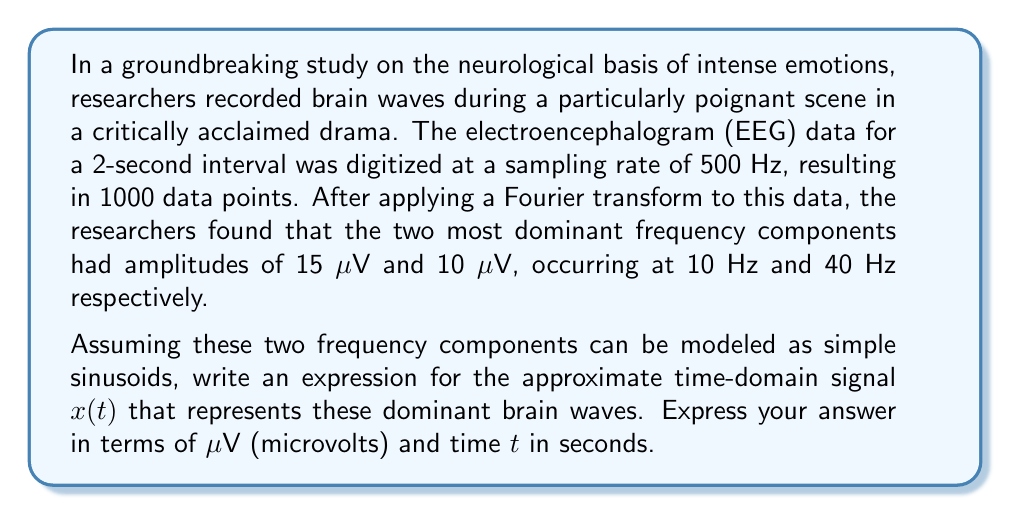Solve this math problem. To solve this problem, we need to understand how the Fourier transform relates to sinusoidal components in the time domain. Each frequency component in the Fourier domain corresponds to a sinusoid in the time domain.

Given:
- Dominant frequency 1: 10 Hz with amplitude 15 μV
- Dominant frequency 2: 40 Hz with amplitude 10 μV

Step 1: Express each component as a sinusoid.
For a sinusoid with amplitude $A$, frequency $f$, and time $t$, the general form is:
$$A \sin(2\pi ft)$$

Component 1: $15 \sin(2\pi \cdot 10t)$
Component 2: $10 \sin(2\pi \cdot 40t)$

Step 2: Sum the two components to get the approximate time-domain signal.
$$x(t) = 15 \sin(2\pi \cdot 10t) + 10 \sin(2\pi \cdot 40t)$$

Step 3: Simplify by expressing frequencies in radians per second.
$\omega = 2\pi f$
For 10 Hz: $\omega_1 = 2\pi \cdot 10 = 20\pi$
For 40 Hz: $\omega_2 = 2\pi \cdot 40 = 80\pi$

Therefore, the final expression is:
$$x(t) = 15 \sin(20\pi t) + 10 \sin(80\pi t)$$

This expression represents the approximate time-domain signal of the dominant brain waves, where $x(t)$ is in microvolts (μV) and $t$ is in seconds.
Answer: $$x(t) = 15 \sin(20\pi t) + 10 \sin(80\pi t)$$
Where $x(t)$ is in μV and $t$ is in seconds. 